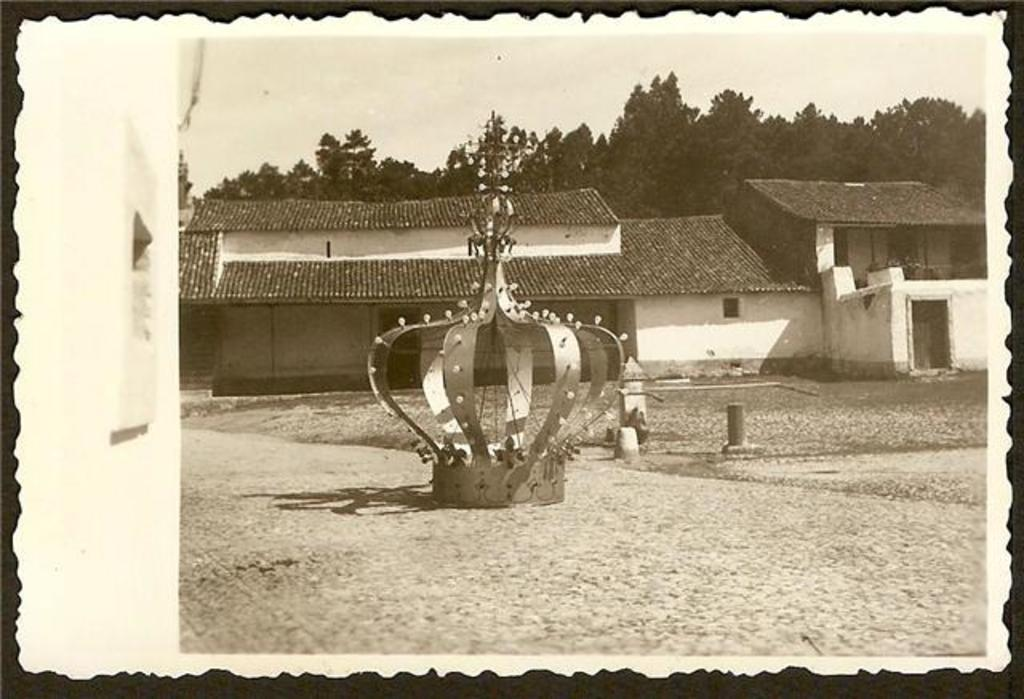What is the main subject in the center of the image? There is a supermarine spitfire in the center of the image. What can be seen in the background of the image? There are houses and trees in the background of the image. What type of chair can be seen in the image? There is no chair present in the image. Can you hear the voice of the supermarine spitfire in the image? The image is a visual representation, so there is no sound or voice associated with the supermarine spitfire. 